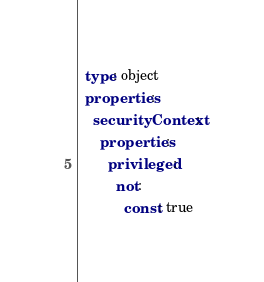<code> <loc_0><loc_0><loc_500><loc_500><_YAML_>  type: object
  properties:
    securityContext:
      properties:
        privileged:
          not:
            const: true</code> 